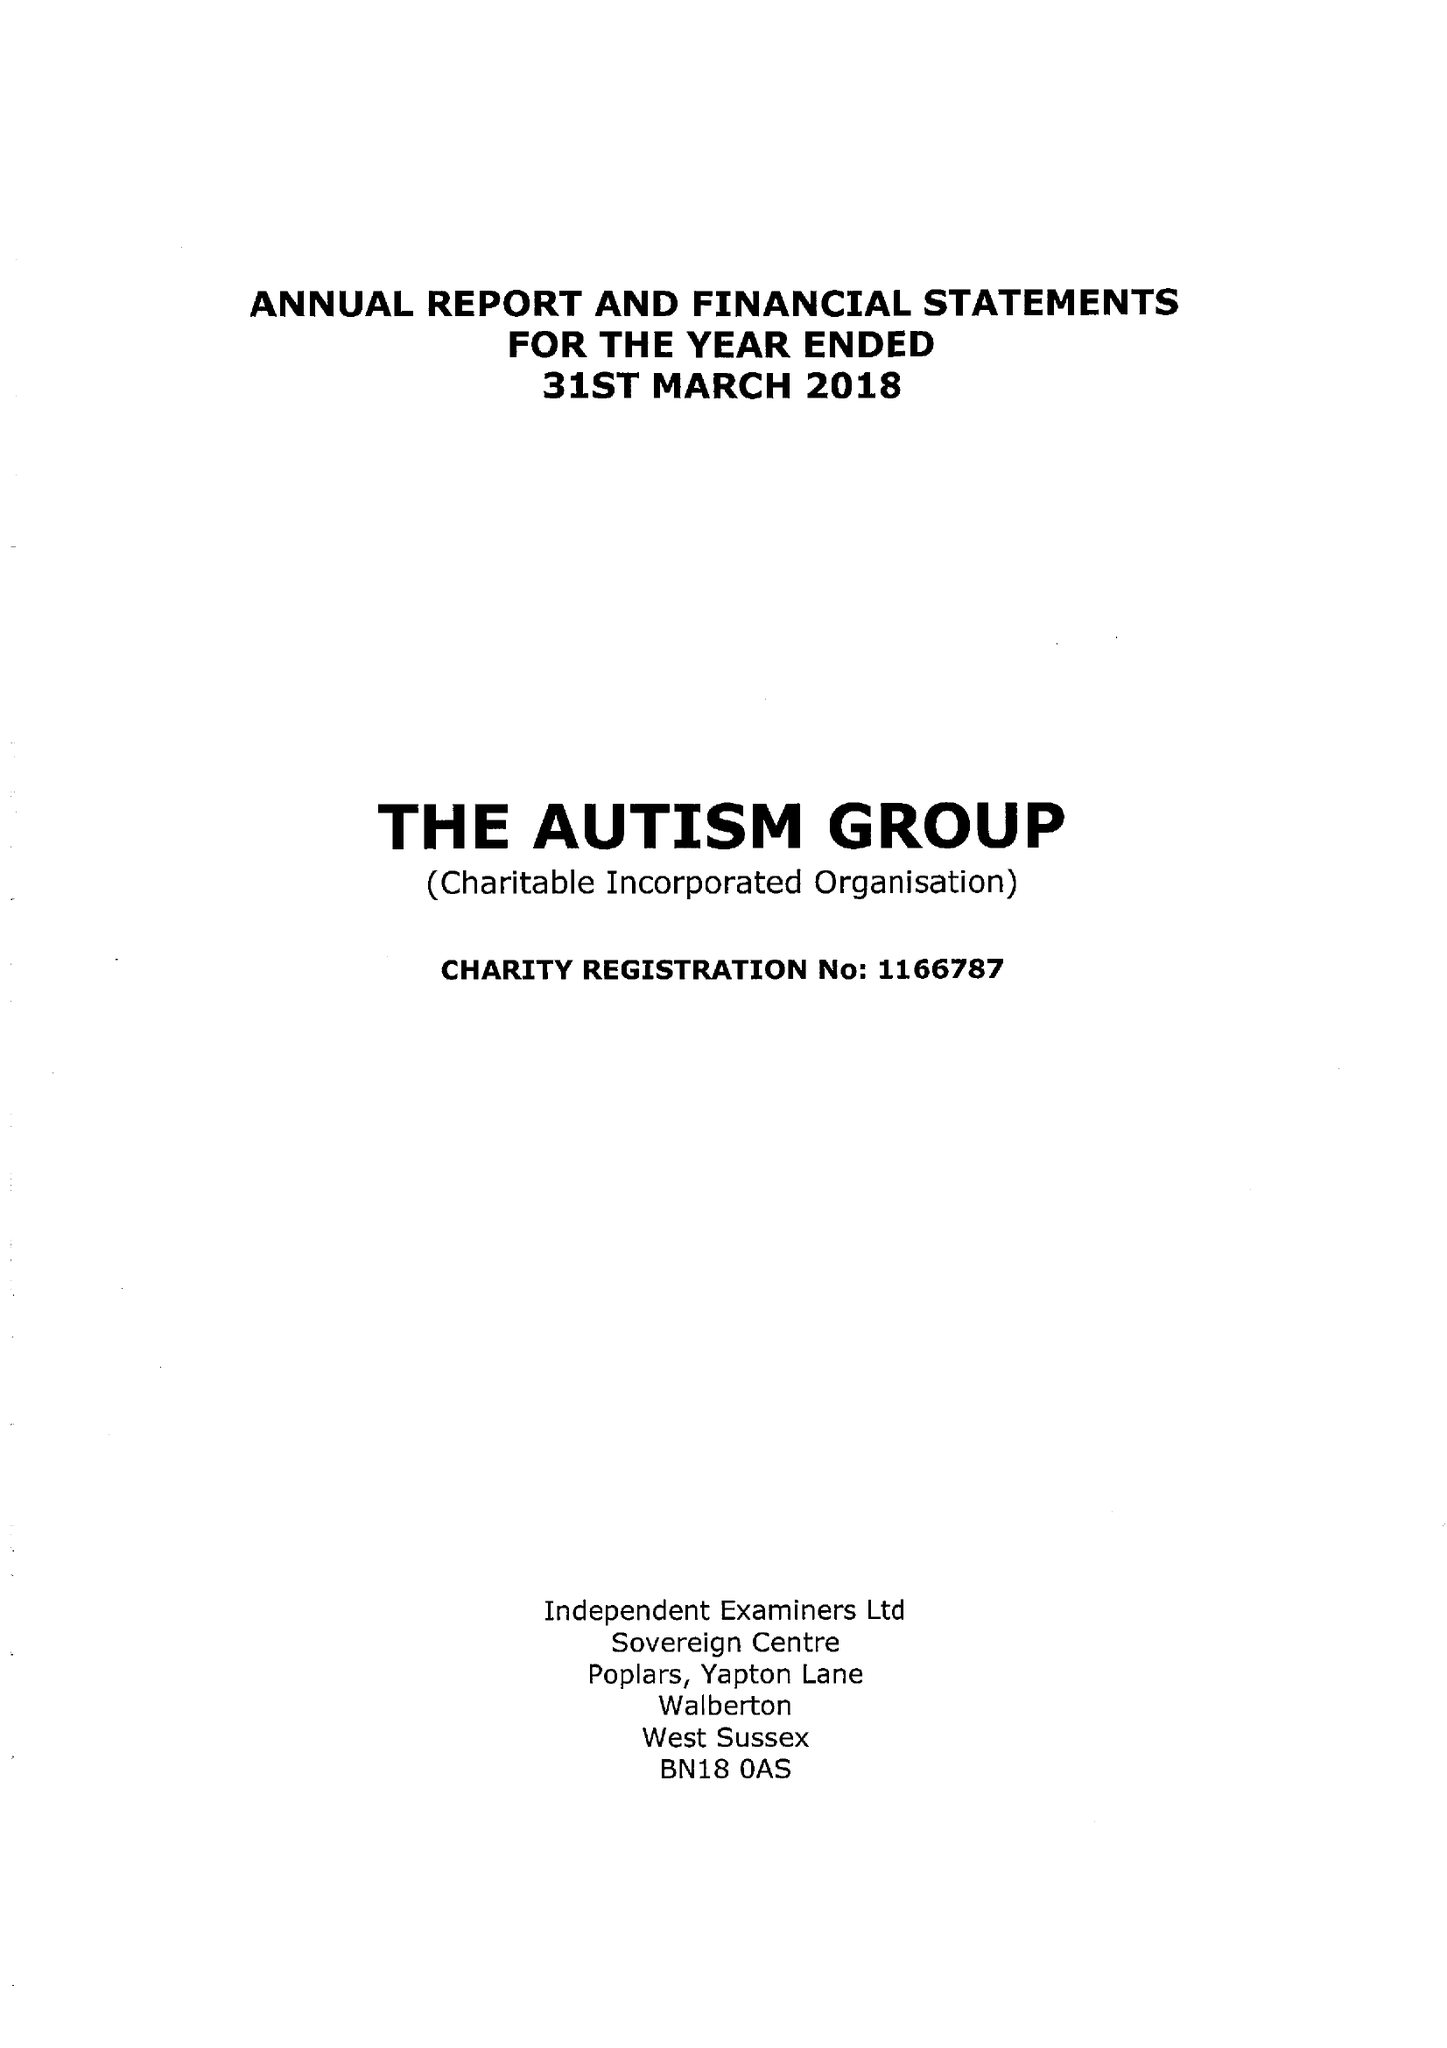What is the value for the income_annually_in_british_pounds?
Answer the question using a single word or phrase. 43447.00 